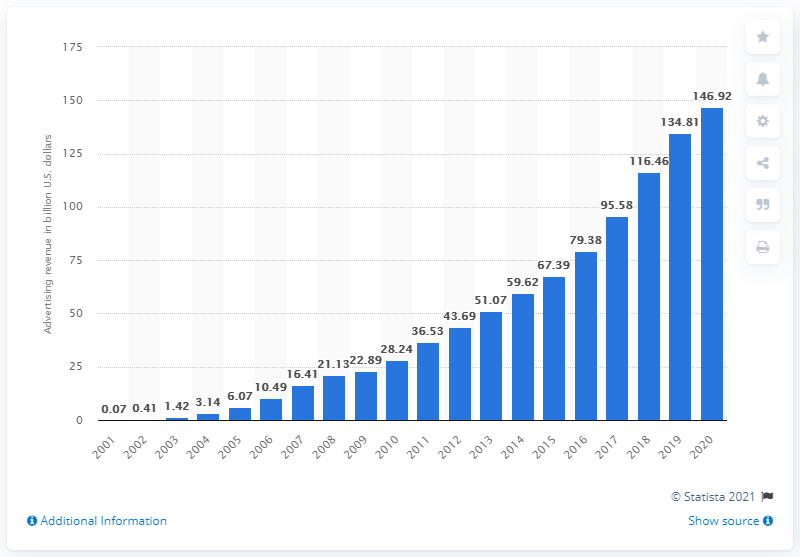Highlight a few significant elements in this photo. Google's ad revenue in 2020 was $146.92 billion. 